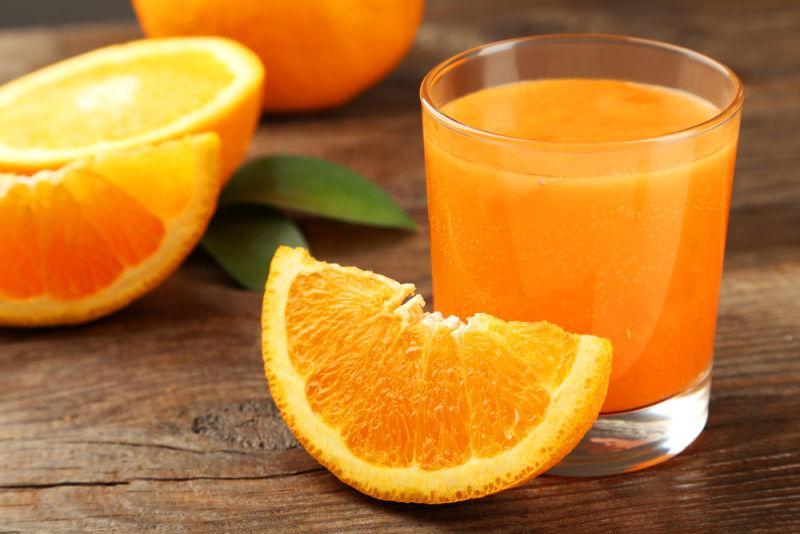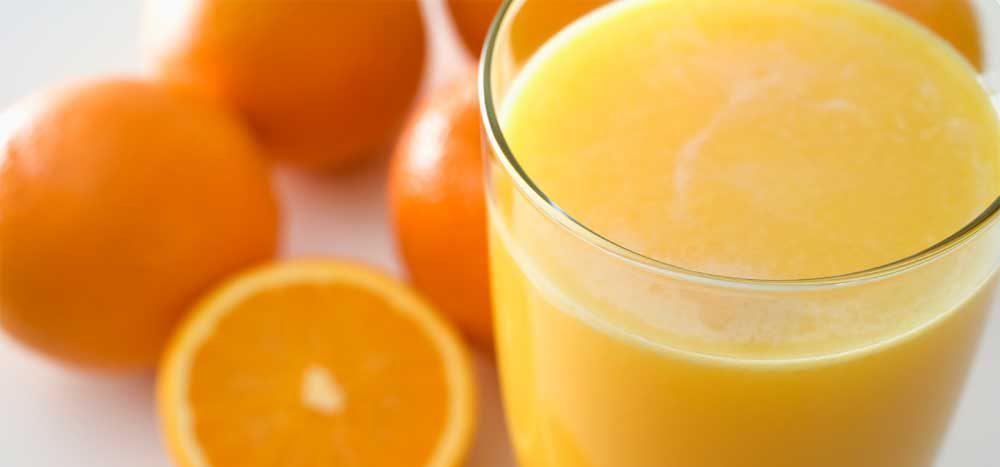The first image is the image on the left, the second image is the image on the right. For the images shown, is this caption "An orange WEDGE rests against a glass of juice." true? Answer yes or no. Yes. The first image is the image on the left, the second image is the image on the right. Evaluate the accuracy of this statement regarding the images: "Glasses of orange juice without straws in them are present in at least one image.". Is it true? Answer yes or no. Yes. 